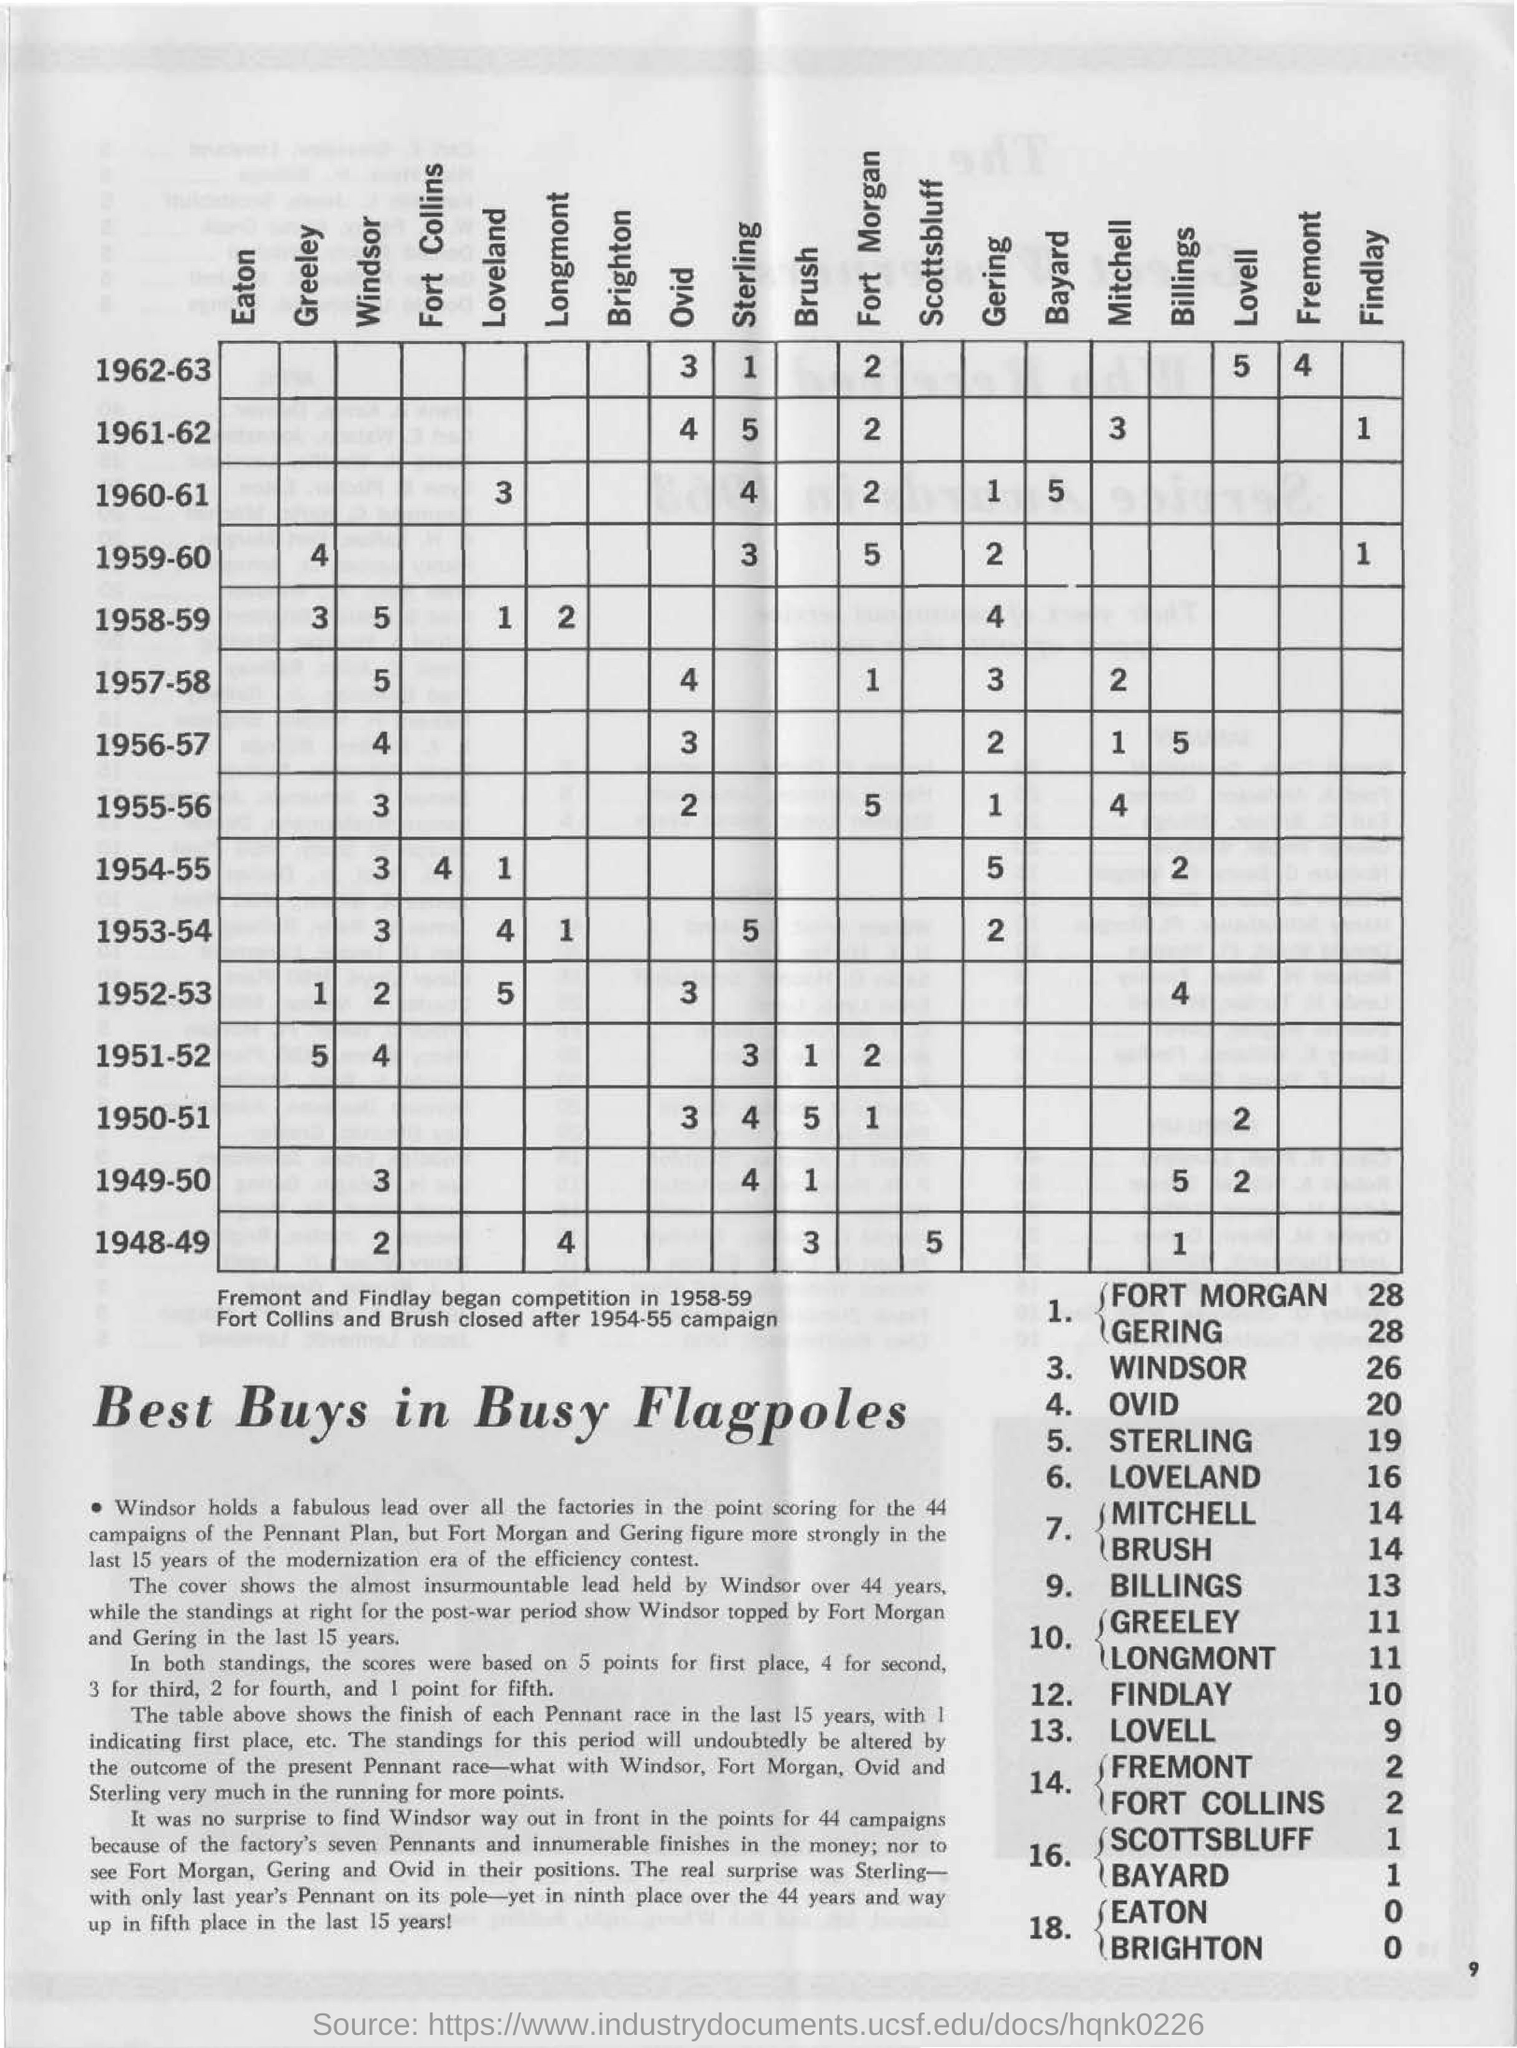Highlight a few significant elements in this photo. The number in the "windsor" and "1957-58" cell is five. What is the number in the cell labeled 'loveland' and '1958-59'? The number on the "Windsor" cell is 5. The number on the "gering" and "1957-58" cell is 3. 